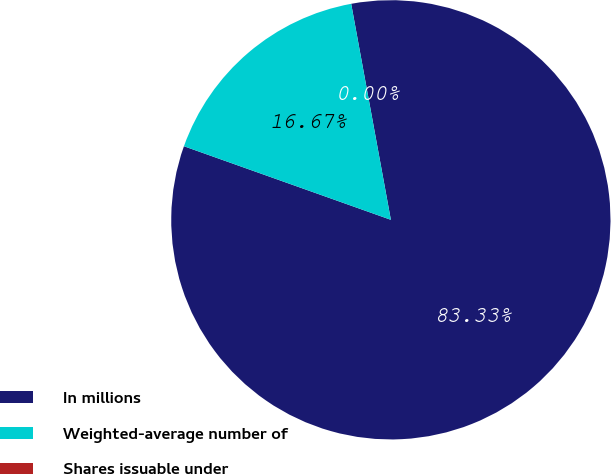<chart> <loc_0><loc_0><loc_500><loc_500><pie_chart><fcel>In millions<fcel>Weighted-average number of<fcel>Shares issuable under<nl><fcel>83.33%<fcel>16.67%<fcel>0.0%<nl></chart> 